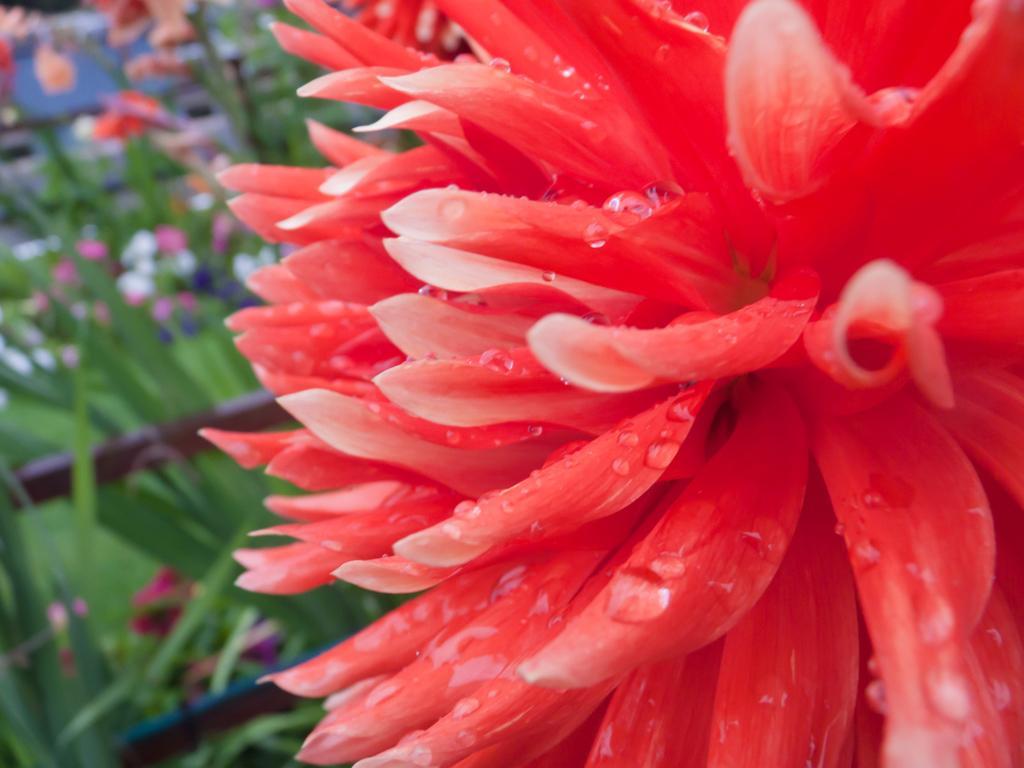Describe this image in one or two sentences. In this image we can see a flower. In the background it is blurry and we can see plants and flowers. 